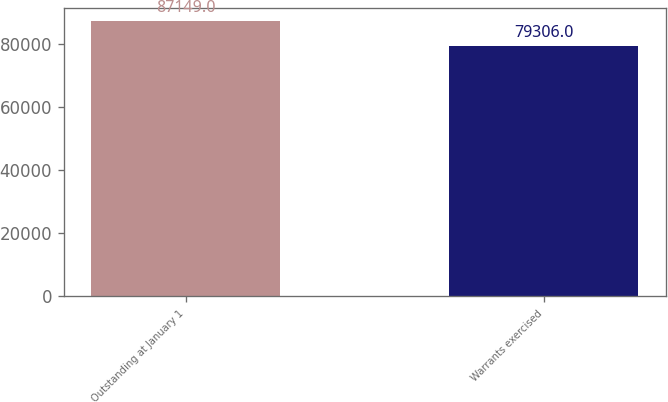<chart> <loc_0><loc_0><loc_500><loc_500><bar_chart><fcel>Outstanding at January 1<fcel>Warrants exercised<nl><fcel>87149<fcel>79306<nl></chart> 